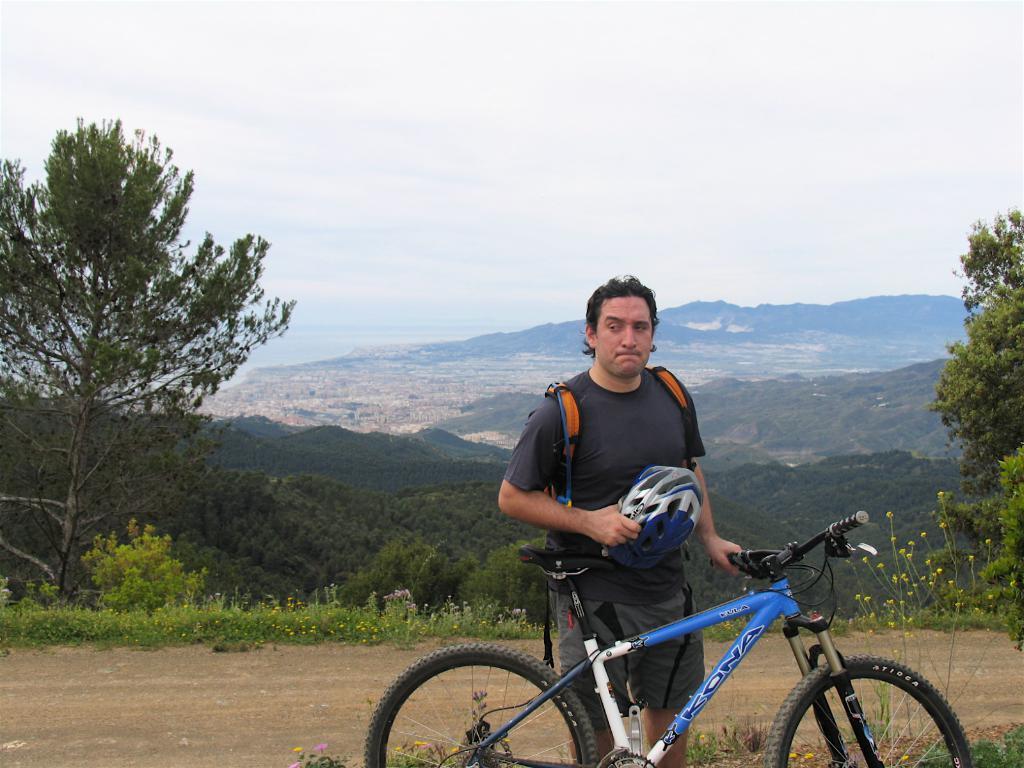How would you summarize this image in a sentence or two? In the center of the image we can see one man standing and he is holding one helmet and cycle. In the background, we can see the sky, clouds, hills, trees, plants, grass, flowers, road etc. 